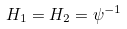Convert formula to latex. <formula><loc_0><loc_0><loc_500><loc_500>H _ { 1 } = H _ { 2 } = \psi ^ { - 1 }</formula> 